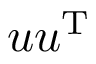Convert formula to latex. <formula><loc_0><loc_0><loc_500><loc_500>u u ^ { T }</formula> 